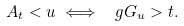Convert formula to latex. <formula><loc_0><loc_0><loc_500><loc_500>A _ { t } < u \iff \ g G _ { u } > t .</formula> 